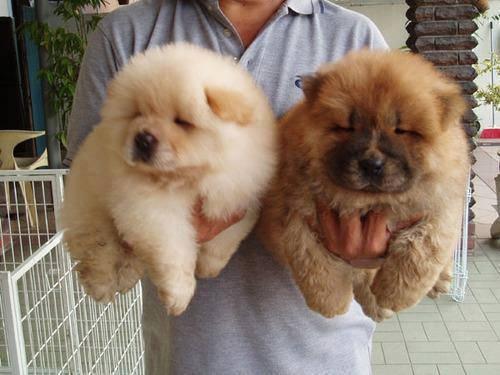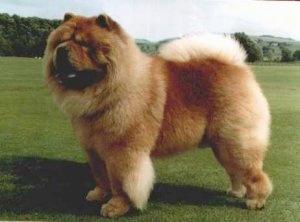The first image is the image on the left, the second image is the image on the right. Analyze the images presented: Is the assertion "The right image contains one adult red-orange chow standing in profile turned leftward, and the left image includes a fluffy young chow facing forward." valid? Answer yes or no. Yes. The first image is the image on the left, the second image is the image on the right. Evaluate the accuracy of this statement regarding the images: "The left image contains one black chow dog.". Is it true? Answer yes or no. No. 